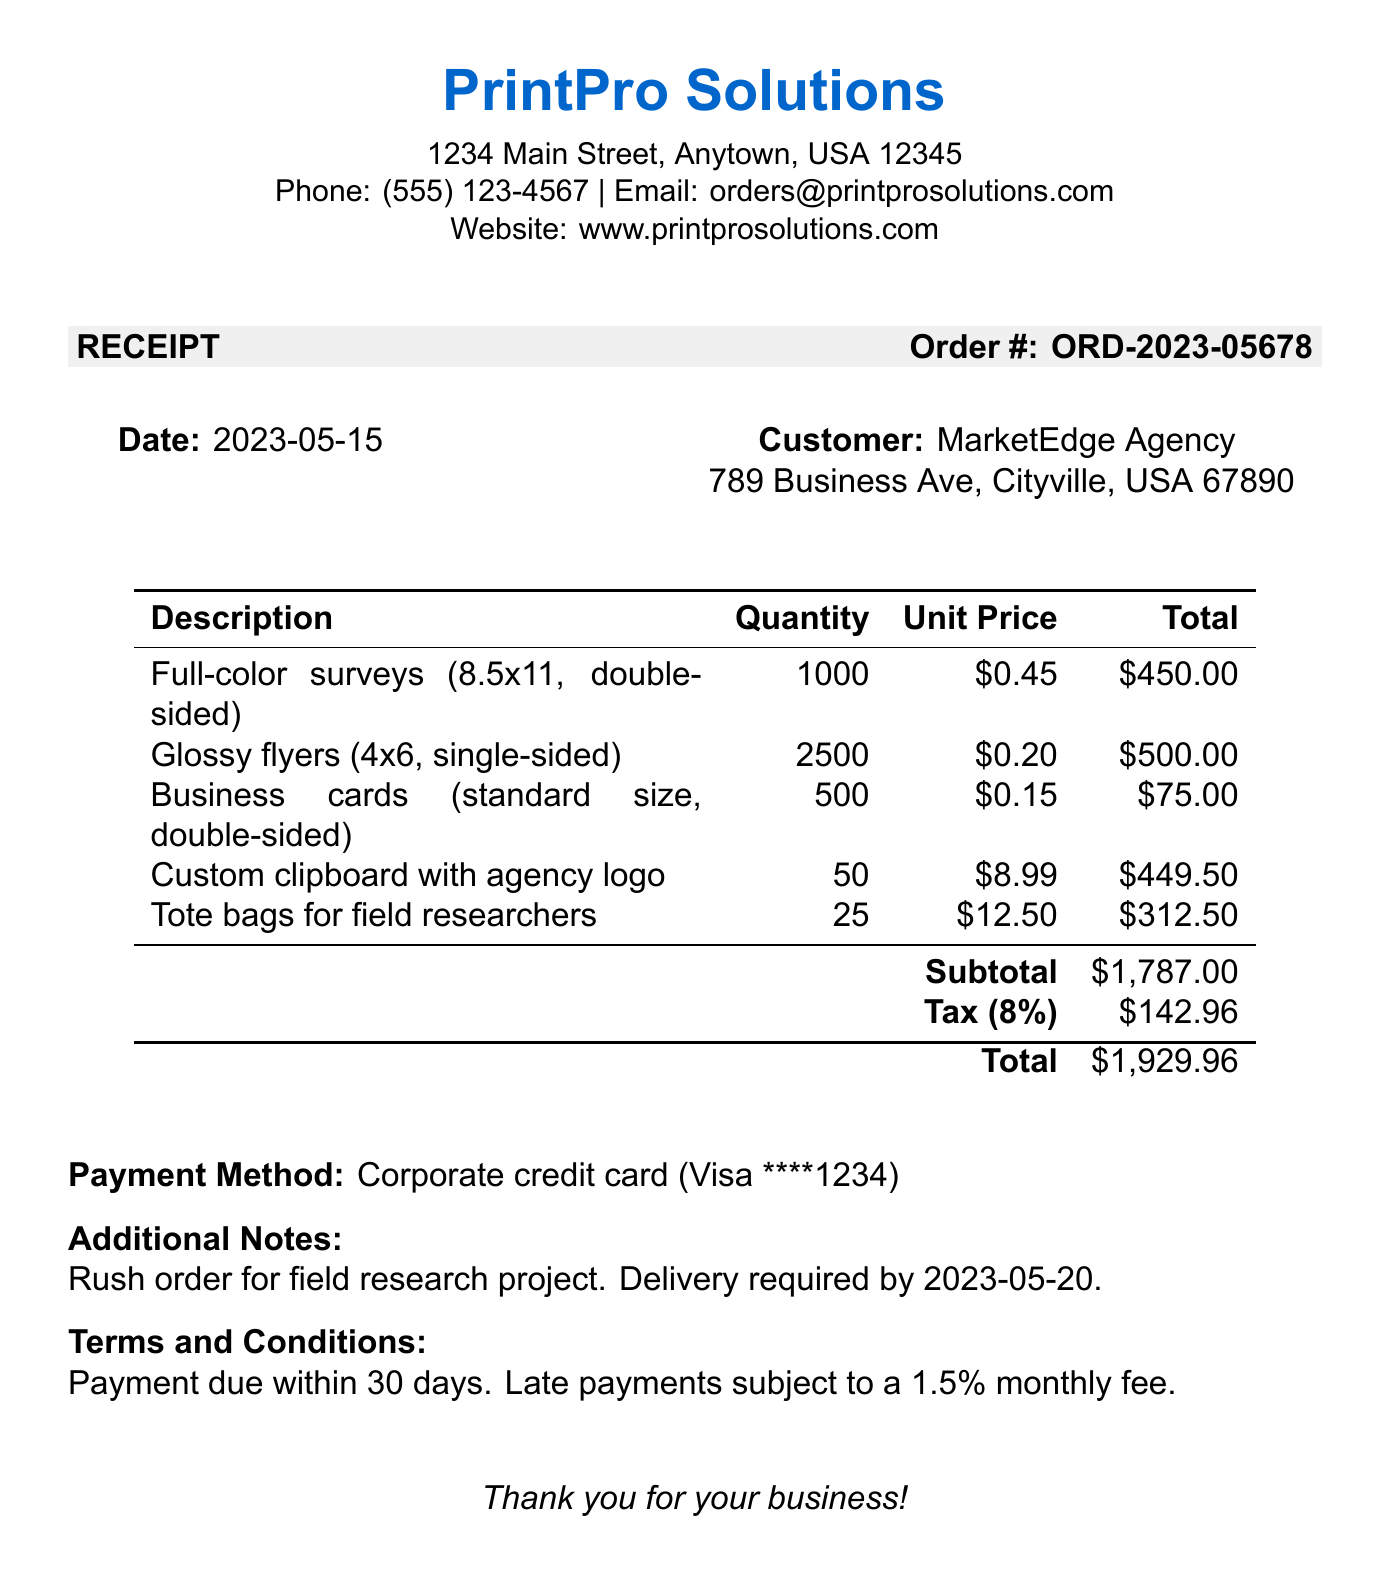what is the business name? The business name is listed at the top of the receipt.
Answer: PrintPro Solutions what is the order number? The order number is clearly indicated in the receipt document.
Answer: ORD-2023-05678 what is the total amount due? The total amount is calculated at the end of the receipt, including tax.
Answer: $1929.96 how many full-color surveys were ordered? The quantity of full-color surveys is provided in the itemized list.
Answer: 1000 what is the tax amount? The tax amount is specified in the subtotal calculations section.
Answer: $142.96 who is the customer? The customer information is detailed in the header section of the receipt.
Answer: MarketEdge Agency what is the date of the order? The date is provided prominently in the document.
Answer: 2023-05-15 what payment method was used? The payment method is clearly outlined towards the end of the receipt.
Answer: Corporate credit card what is the delivery requirement noted in the additional notes? The additional notes specify urgency related to the delivery timeline.
Answer: Delivery required by 2023-05-20 what are the terms regarding late payments? The terms and conditions section describes the late payment policy.
Answer: Late payments subject to a 1.5% monthly fee 